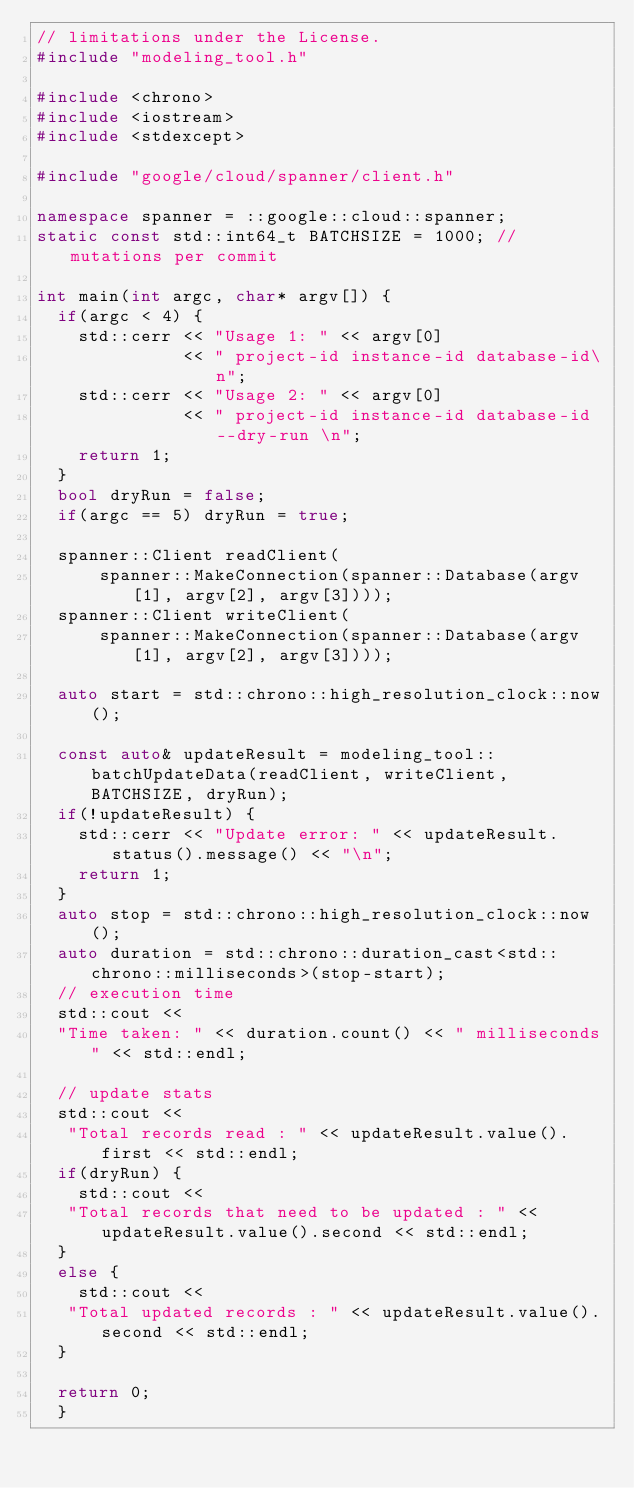<code> <loc_0><loc_0><loc_500><loc_500><_C++_>// limitations under the License.
#include "modeling_tool.h"

#include <chrono>
#include <iostream>
#include <stdexcept>

#include "google/cloud/spanner/client.h"

namespace spanner = ::google::cloud::spanner;
static const std::int64_t BATCHSIZE = 1000; // mutations per commit 

int main(int argc, char* argv[]) {
  if(argc < 4) {
    std::cerr << "Usage 1: " << argv[0]
              << " project-id instance-id database-id\n";
    std::cerr << "Usage 2: " << argv[0]
              << " project-id instance-id database-id --dry-run \n";              
    return 1;
  }
  bool dryRun = false;
  if(argc == 5) dryRun = true;

  spanner::Client readClient(
      spanner::MakeConnection(spanner::Database(argv[1], argv[2], argv[3])));
  spanner::Client writeClient(
      spanner::MakeConnection(spanner::Database(argv[1], argv[2], argv[3])));
  
  auto start = std::chrono::high_resolution_clock::now();
  
  const auto& updateResult = modeling_tool::batchUpdateData(readClient, writeClient, BATCHSIZE, dryRun);
  if(!updateResult) {
    std::cerr << "Update error: " << updateResult.status().message() << "\n";
    return 1;
  }
  auto stop = std::chrono::high_resolution_clock::now();
  auto duration = std::chrono::duration_cast<std::chrono::milliseconds>(stop-start);
  // execution time
  std::cout << 
  "Time taken: " << duration.count() << " milliseconds" << std::endl;

  // update stats
  std::cout << 
   "Total records read : " << updateResult.value().first << std::endl;
  if(dryRun) {
    std::cout << 
   "Total records that need to be updated : " << updateResult.value().second << std::endl; 
  }
  else {
    std::cout << 
   "Total updated records : " << updateResult.value().second << std::endl;
  }
  
  return 0;
  } </code> 